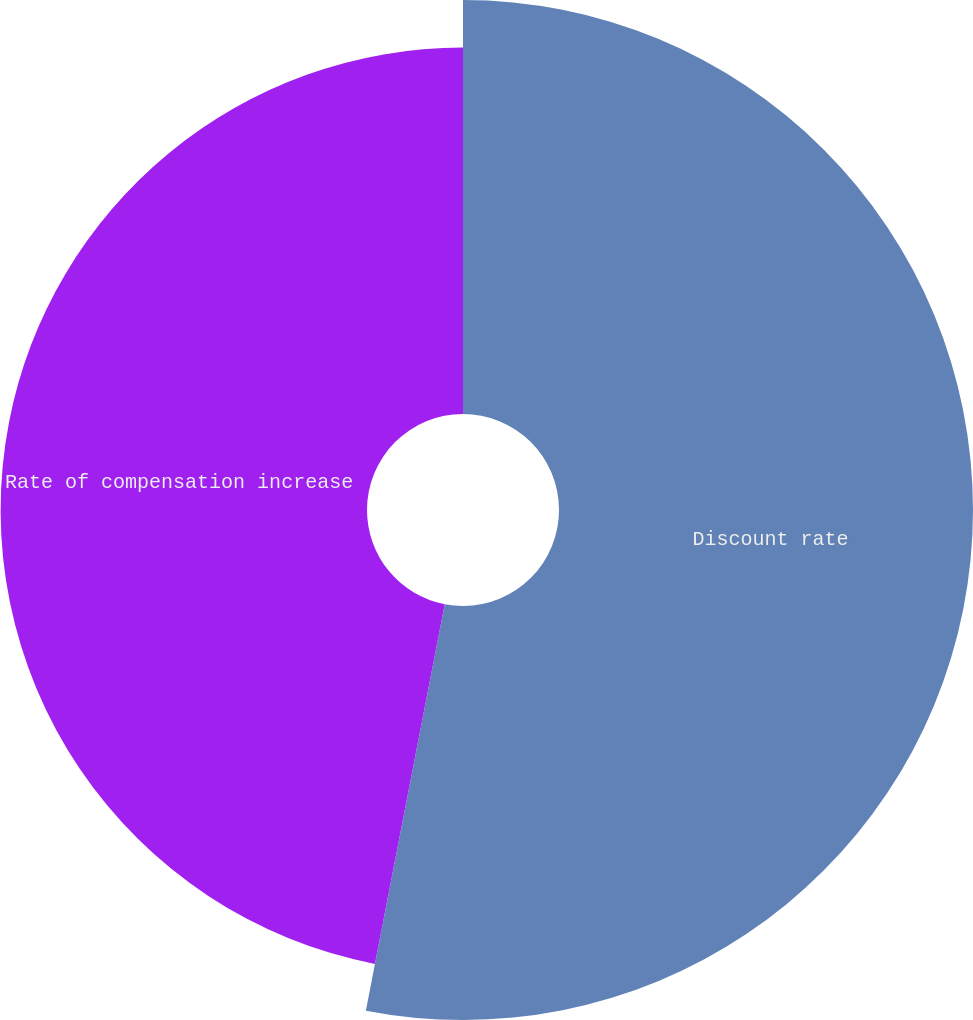<chart> <loc_0><loc_0><loc_500><loc_500><pie_chart><fcel>Discount rate<fcel>Rate of compensation increase<nl><fcel>53.05%<fcel>46.95%<nl></chart> 